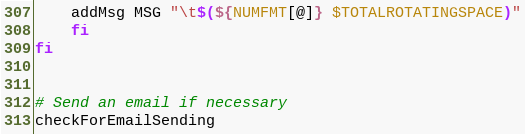Convert code to text. <code><loc_0><loc_0><loc_500><loc_500><_Bash_>	addMsg MSG "\t$(${NUMFMT[@]} $TOTALROTATINGSPACE)"
    fi
fi


# Send an email if necessary
checkForEmailSending


</code> 